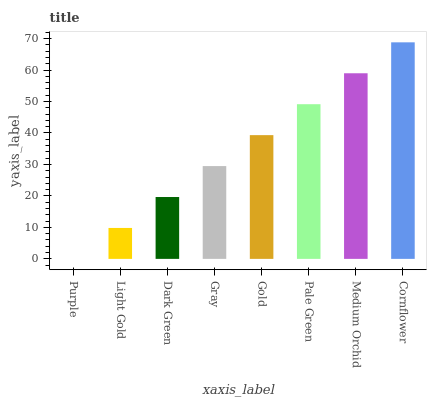Is Purple the minimum?
Answer yes or no. Yes. Is Cornflower the maximum?
Answer yes or no. Yes. Is Light Gold the minimum?
Answer yes or no. No. Is Light Gold the maximum?
Answer yes or no. No. Is Light Gold greater than Purple?
Answer yes or no. Yes. Is Purple less than Light Gold?
Answer yes or no. Yes. Is Purple greater than Light Gold?
Answer yes or no. No. Is Light Gold less than Purple?
Answer yes or no. No. Is Gold the high median?
Answer yes or no. Yes. Is Gray the low median?
Answer yes or no. Yes. Is Medium Orchid the high median?
Answer yes or no. No. Is Gold the low median?
Answer yes or no. No. 